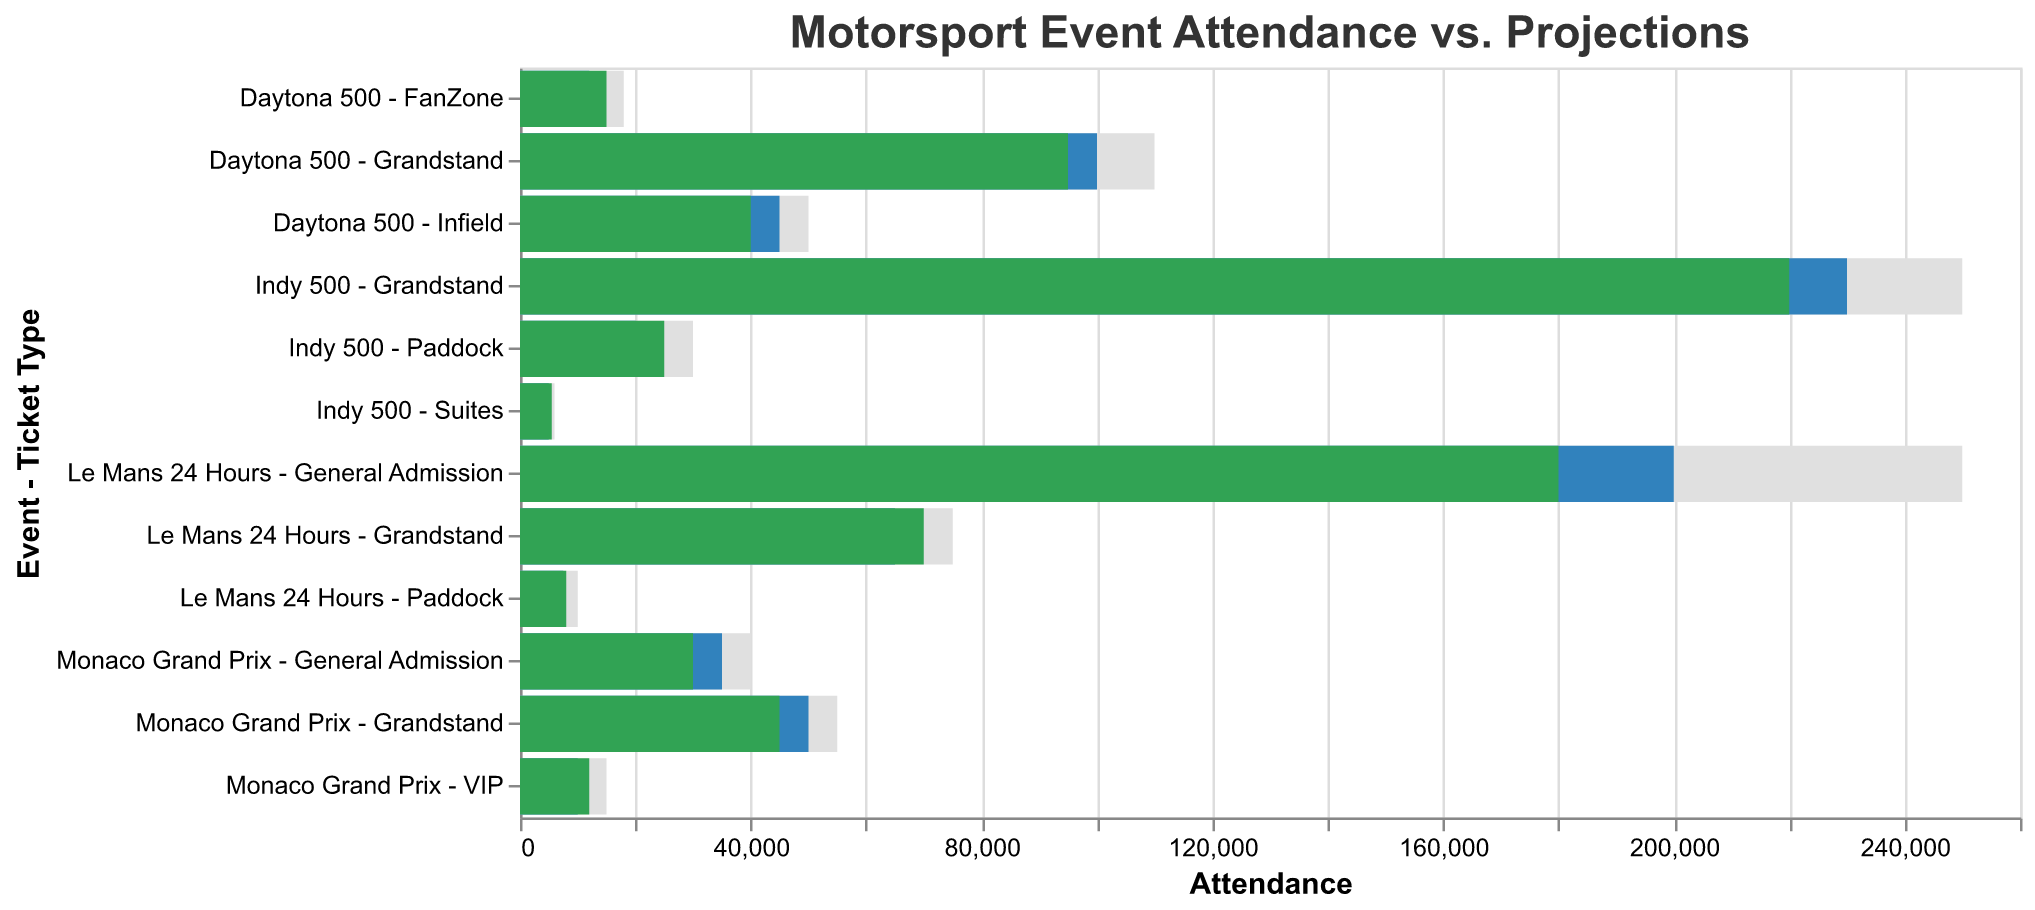How many unique motorsport events are represented in the chart? The chart segments data by different motorsport events, identifiable by their names. By counting them, we find four unique events: Monaco Grand Prix, Le Mans 24 Hours, Indy 500, and Daytona 500.
Answer: 4 Which ticket type had the highest actual attendance at the Indy 500? Look into the segments under the event "Indy 500" and identify the ticket type with the longest green bar, representing actual attendance. The Grandstand ticket had the highest actual attendance.
Answer: Grandstand What's the difference between the projected and actual attendance for the Le Mans 24 Hours Grandstand ticket type? For Le Mans 24 Hours Grandstand, subtract the projected attendance from the actual attendance: 70000 - 65000 = 5000.
Answer: 5000 Did the Monaco Grand Prix VIP ticket type exceed its projected attendance? Compare the bar lengths for actual and projected attendance under Monaco Grand Prix - VIP. The actual bar (green) is longer than the projected bar (blue), indicating that actual attendance exceeded projections.
Answer: Yes What's the combined actual attendance for all general admission ticket types? Sum the green bars representing actual attendance across all general admission ticket types: 30000 (Monaco Grand Prix) + 180000 (Le Mans 24 Hours) + 40000 (Daytona 500) = 250000.
Answer: 250000 Which event had the largest discrepancy between projected and actual attendance in any ticket type? Compare the projected and actual bars across all events and ticket types to find the largest discrepancy. The discrepancy for Le Mans 24 Hours (General Admission) is substantial, with actual attendance at 180000 and projected at 200000, a difference of 20000.
Answer: Le Mans 24 Hours (General Admission) What is the highest max capacity for ticket types across all events? Identify the longest grey bar that represents the maximum capacity in the chart. The highest max capacity is 250000 for Le Mans 24 Hours (General Admission) and Indy 500 (Grandstand).
Answer: 250000 Did the Daytona 500 Infield ticket type meet its projected attendance? Compare the actual and projected bars for the Daytona 500 Infield. The actual bar (green) is shorter than the projected bar (blue), indicating it did not meet the projections.
Answer: No 